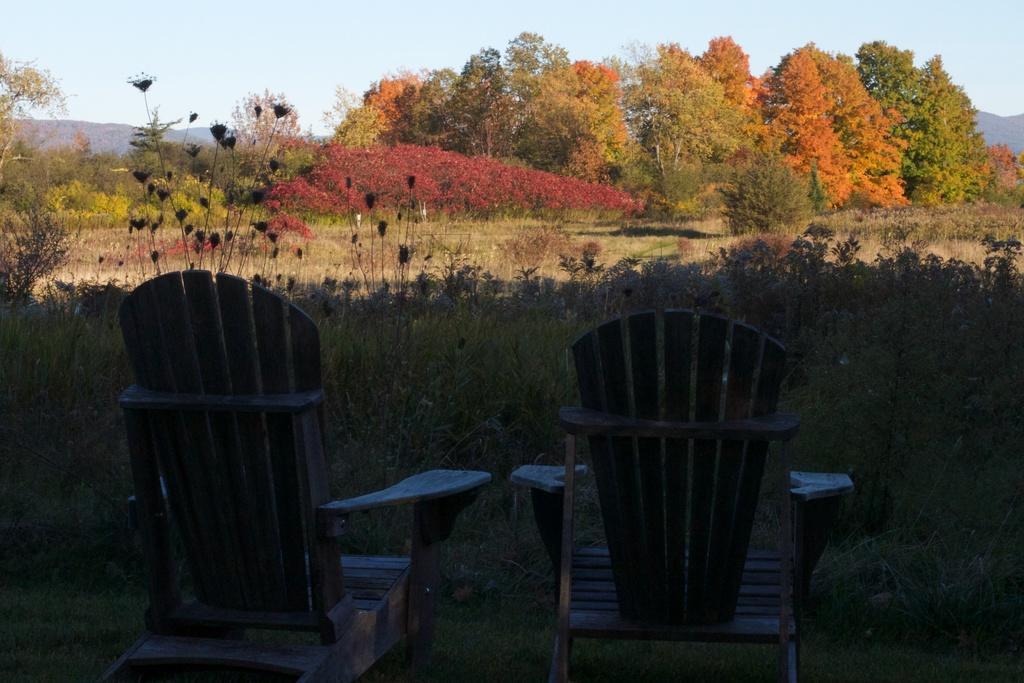How would you summarize this image in a sentence or two? In this image there are two wooden chairs at the bottom. In the background there are so many trees. At the top there is the sky. In front of the chairs there is grass. 